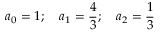Convert formula to latex. <formula><loc_0><loc_0><loc_500><loc_500>a _ { 0 } = 1 ; \quad a _ { 1 } = { \frac { 4 } { 3 } } ; \quad a _ { 2 } = { \frac { 1 } { 3 } }</formula> 